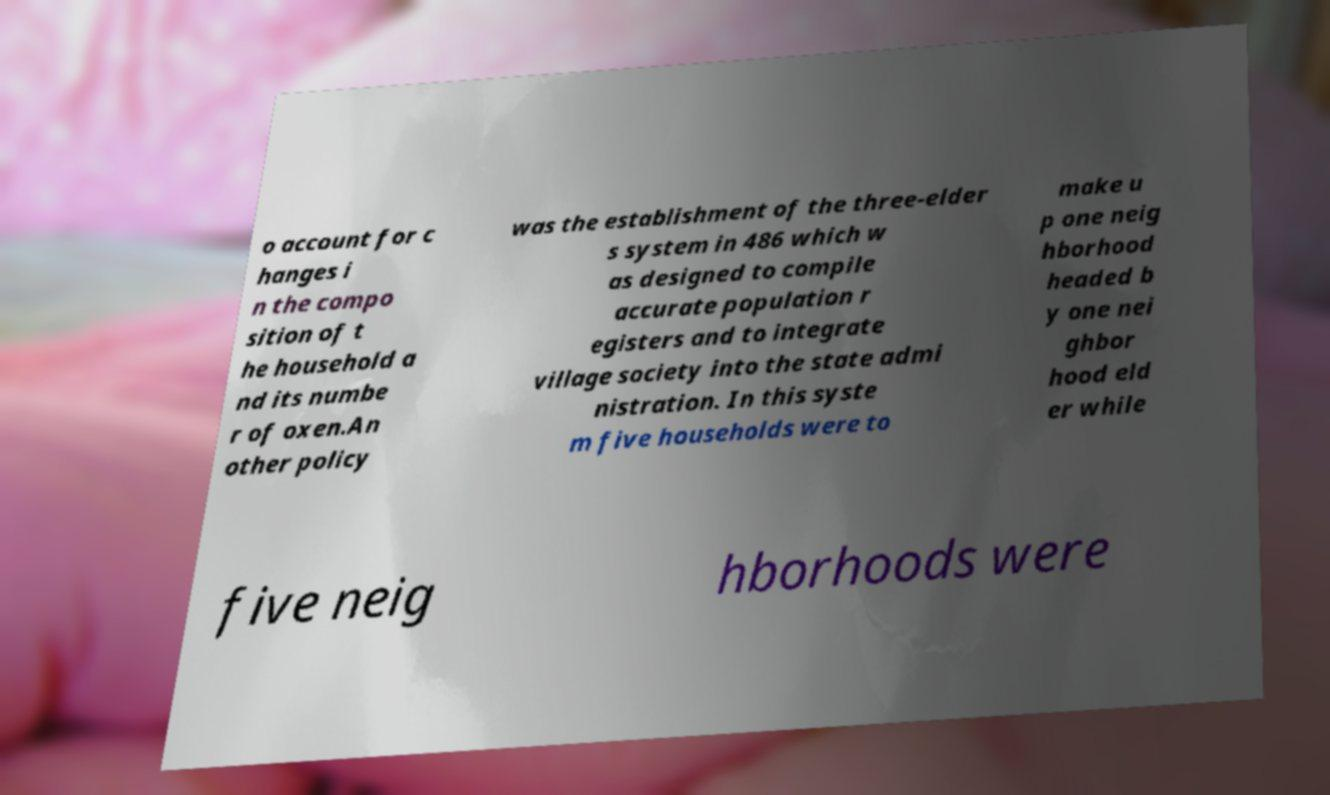What messages or text are displayed in this image? I need them in a readable, typed format. o account for c hanges i n the compo sition of t he household a nd its numbe r of oxen.An other policy was the establishment of the three-elder s system in 486 which w as designed to compile accurate population r egisters and to integrate village society into the state admi nistration. In this syste m five households were to make u p one neig hborhood headed b y one nei ghbor hood eld er while five neig hborhoods were 